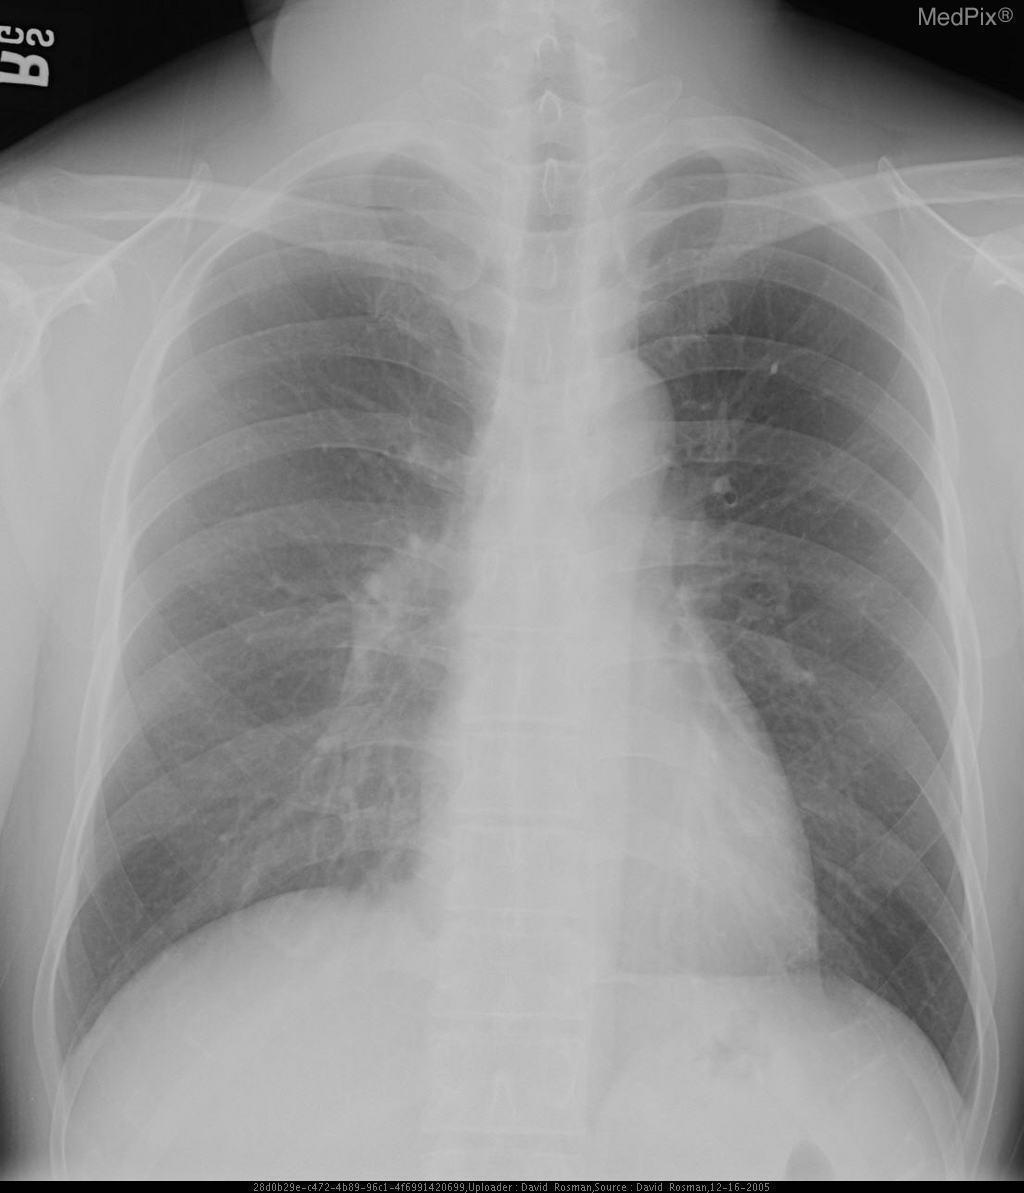Is there anything wrong with the lungs?
Answer briefly. No. What test or procedure might reveal the diagnosis?
Short answer required. Head/neck ct. What can be done to get to a diagnosis?
Be succinct. Biopsy. Is this image sufficient for a diagnosis?
Concise answer only. No. Is the image enough to diagnose?
Answer briefly. No. Did this patient sustain physical damage?
Concise answer only. No. Do you suspect a physical injury?
Write a very short answer. No. 